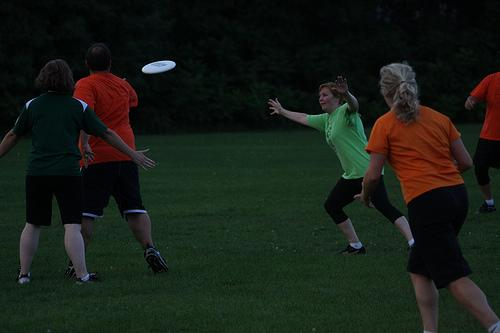What kind of shirt is the woman in green wearing, and what is she doing? The woman is wearing a green short sleeve t-shirt, running toward the flying frisbee. Describe the surface and surroundings where the people are playing the sport. The people are playing on a field with short green grass, trees, and bushes around them. In a single sentence, summarize the main action happening within the image. A group of adults is playing frisbee in a park, running and reaching for the white disc in mid-air. What object is the focus of the participants' attention in the image? A white frisbee flying through the air is the center of attention for the participants. Briefly describe the setting in which the people can be found in the image. The people are in a park with short green grass, trees, and bushes in the background. Point out the specific action being performed by the man in the orange shirt. The man in the orange shirt is throwing a frisbee. Mention the primary activity taking place and the group of people involved in the image. A sports team of five adults is playing frisbee on a field and running toward the flying disc. What clothing item can you see on a person's feet and what color are they? I can see black and white tennis shoes on a person's feet. What type of shirt is a blonde woman wearing in the image, and which color is it? The blonde woman is wearing a short sleeve orange t-shirt. What is the overall atmosphere or theme of the image? The image captures a lively atmosphere of a group of people enjoying a sport together at night time. 